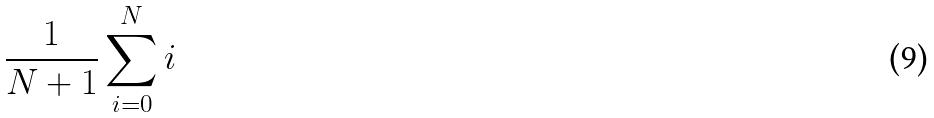<formula> <loc_0><loc_0><loc_500><loc_500>\frac { 1 } { N + 1 } \sum _ { i = 0 } ^ { N } i</formula> 